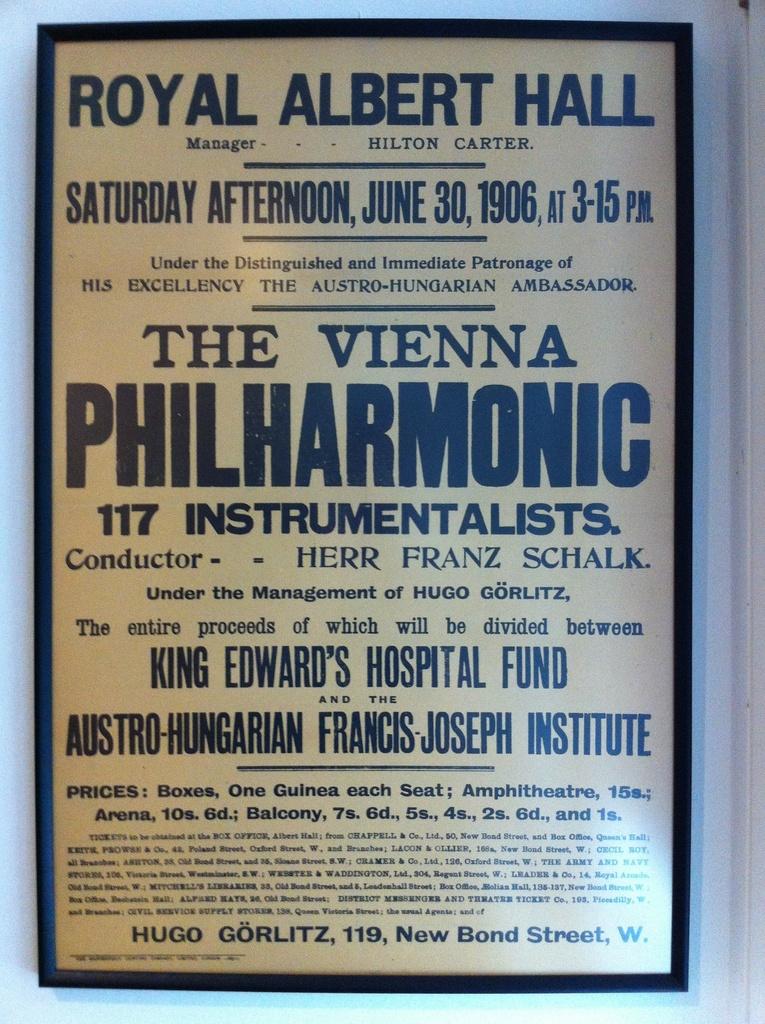What day is this performance on?
Offer a very short reply. Saturday. What venue is the concert at?
Your answer should be very brief. Royal albert hall. 